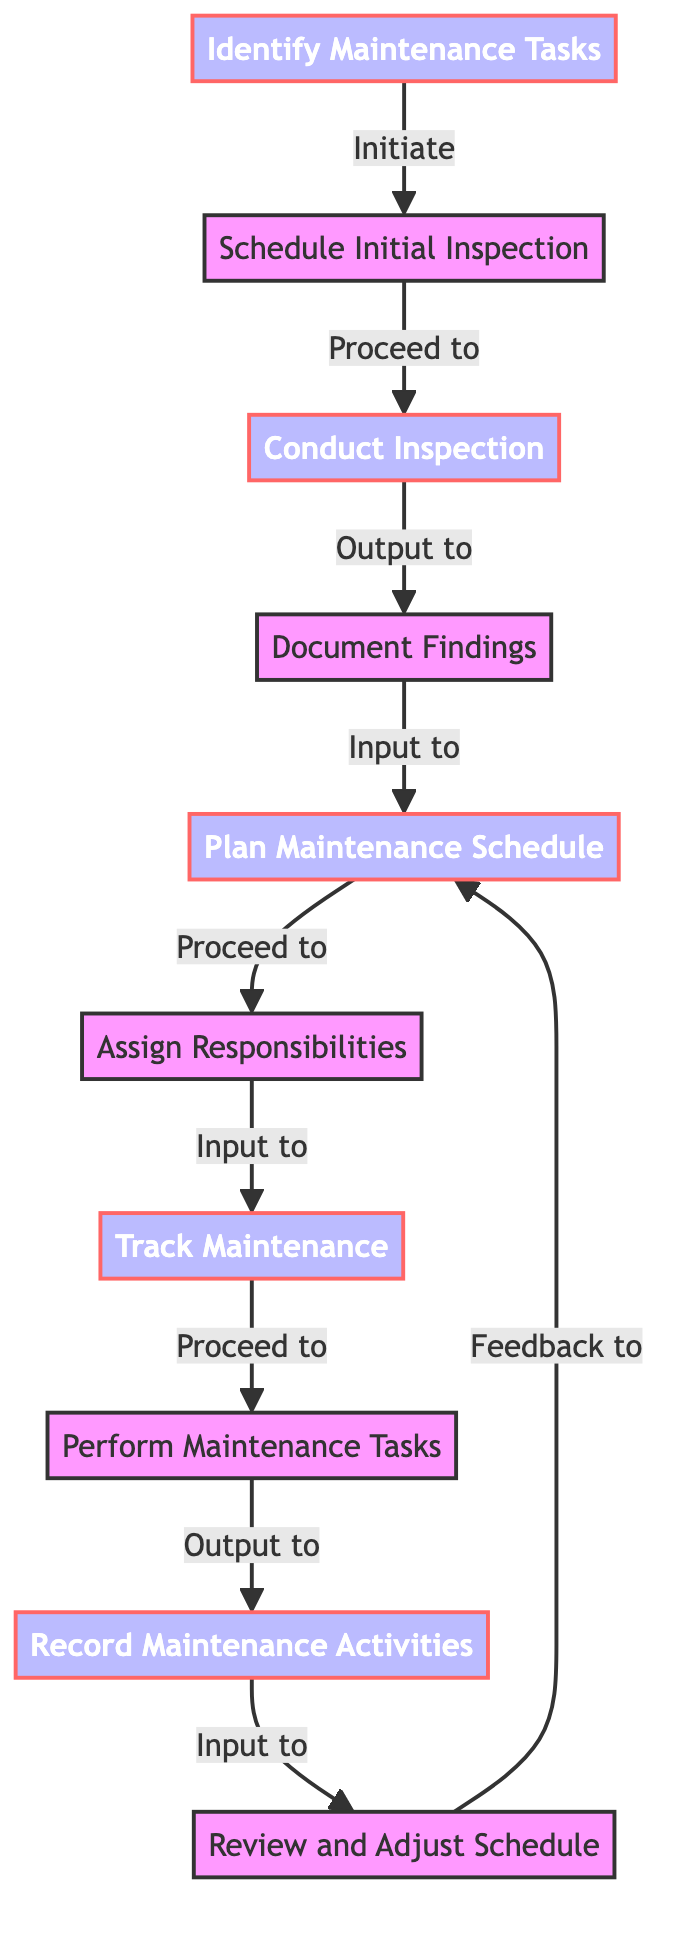What is the first step in the workflow? The diagram indicates that the first step in the workflow is "Identify Maintenance Tasks," as it's the initial node in the directed graph.
Answer: Identify Maintenance Tasks How many nodes are in the diagram? By counting the nodes provided in the data, there are a total of ten distinct nodes representing different steps in the workflow.
Answer: 10 What label is associated with the edge from node 1 to node 2? The edge labeled "Initiate" connects node 1 ("Identify Maintenance Tasks") to node 2 ("Schedule Initial Inspection"), which describes the action taken.
Answer: Initiate Which node follows "Track Maintenance"? The diagram shows that "Track Maintenance" is followed by "Perform Maintenance Tasks," as indicated by the directed edge connecting these two nodes.
Answer: Perform Maintenance Tasks What happens after "Review and Adjust Schedule"? After "Review and Adjust Schedule," the workflow directs back to "Plan Maintenance Schedule," indicating a cyclical feedback loop for continuous improvement based on previous findings.
Answer: Plan Maintenance Schedule How many edges are in the diagram? Counting the relationships represented by the edges, there are ten edges that connect the various nodes in the workflow.
Answer: 10 What is the last step before recording maintenance activities? The last step before recording maintenance activities is "Perform Maintenance Tasks," as indicated by the flow from one node to the other leading into this action.
Answer: Perform Maintenance Tasks Which two nodes have no incoming edges? The nodes "Identify Maintenance Tasks" and "Schedule Initial Inspection" stand out since they do not have any other nodes pointing to them, signifying they are the starting points in the flow.
Answer: Identify Maintenance Tasks, Schedule Initial Inspection What type of diagram is represented? This diagram falls into the category of a directed graph, which showcases the flow and dependencies among multiple nodes within a defined workflow.
Answer: Directed Graph 